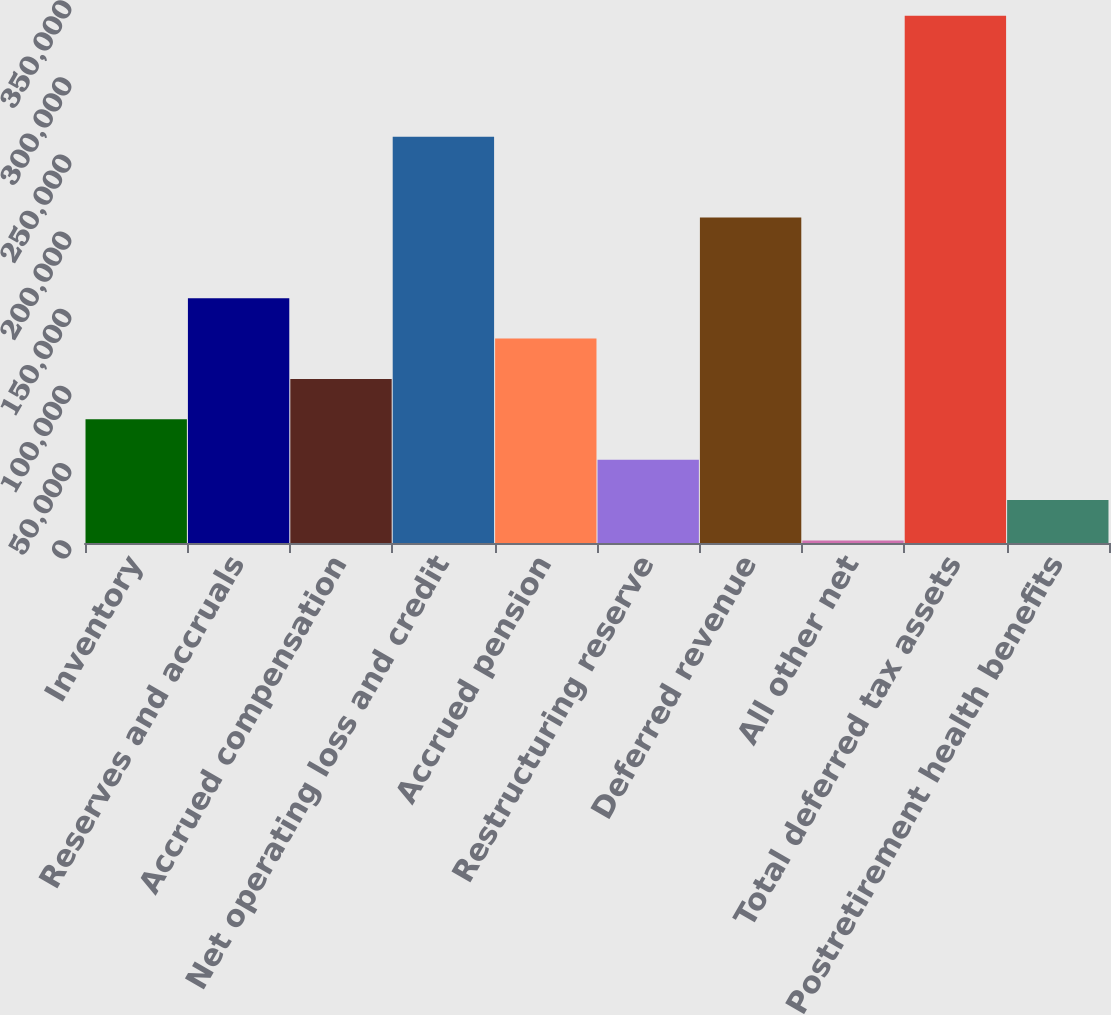Convert chart. <chart><loc_0><loc_0><loc_500><loc_500><bar_chart><fcel>Inventory<fcel>Reserves and accruals<fcel>Accrued compensation<fcel>Net operating loss and credit<fcel>Accrued pension<fcel>Restructuring reserve<fcel>Deferred revenue<fcel>All other net<fcel>Total deferred tax assets<fcel>Postretirement health benefits<nl><fcel>80158.6<fcel>158651<fcel>106323<fcel>263308<fcel>132487<fcel>53994.4<fcel>210980<fcel>1666<fcel>341801<fcel>27830.2<nl></chart> 